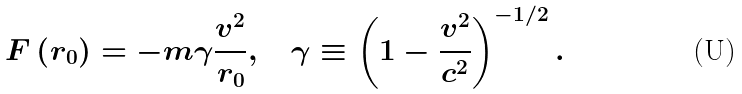<formula> <loc_0><loc_0><loc_500><loc_500>F \left ( r _ { 0 } \right ) = - m \gamma \frac { v ^ { 2 } } { r _ { 0 } } , \quad \gamma \equiv \left ( 1 - \frac { v ^ { 2 } } { c ^ { 2 } } \right ) ^ { - 1 / 2 } .</formula> 